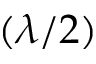<formula> <loc_0><loc_0><loc_500><loc_500>( \lambda / 2 )</formula> 